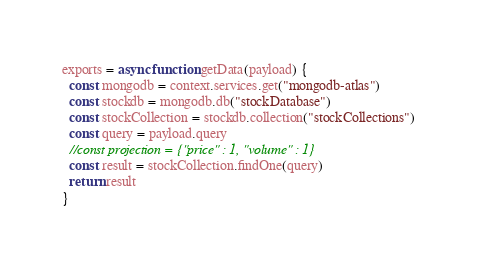Convert code to text. <code><loc_0><loc_0><loc_500><loc_500><_JavaScript_>exports = async function getData(payload) {
  const mongodb = context.services.get("mongodb-atlas")
  const stockdb = mongodb.db("stockDatabase")
  const stockCollection = stockdb.collection("stockCollections")
  const query = payload.query
  //const projection = {"price" : 1, "volume" : 1}
  const result = stockCollection.findOne(query)
  return result
}
</code> 